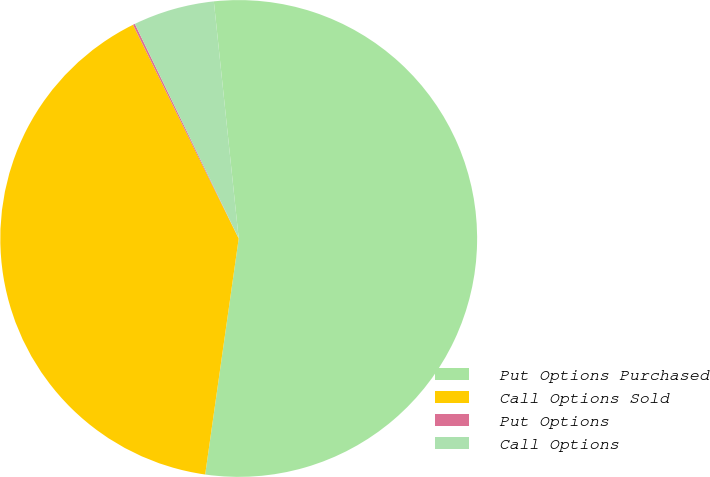Convert chart to OTSL. <chart><loc_0><loc_0><loc_500><loc_500><pie_chart><fcel>Put Options Purchased<fcel>Call Options Sold<fcel>Put Options<fcel>Call Options<nl><fcel>53.91%<fcel>40.44%<fcel>0.14%<fcel>5.51%<nl></chart> 